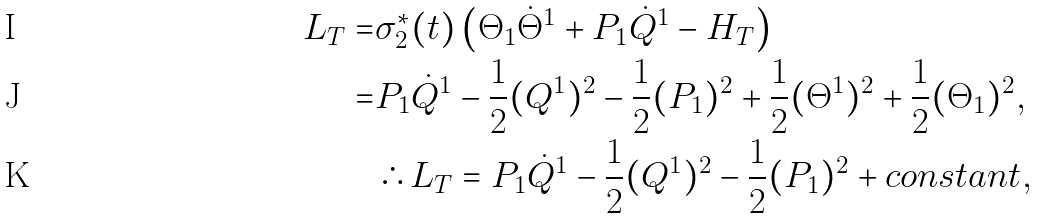<formula> <loc_0><loc_0><loc_500><loc_500>L _ { T } = & \sigma ^ { * } _ { 2 } ( t ) \left ( \Theta _ { 1 } \dot { \Theta } ^ { 1 } + P _ { 1 } \dot { Q } ^ { 1 } - H _ { T } \right ) \\ = & P _ { 1 } \dot { Q } ^ { 1 } - \frac { 1 } { 2 } ( Q ^ { 1 } ) ^ { 2 } - \frac { 1 } { 2 } ( P _ { 1 } ) ^ { 2 } + \frac { 1 } { 2 } ( \Theta ^ { 1 } ) ^ { 2 } + \frac { 1 } { 2 } ( \Theta _ { 1 } ) ^ { 2 } , \\ & \therefore L _ { T } = P _ { 1 } \dot { Q } ^ { 1 } - \frac { 1 } { 2 } ( Q ^ { 1 } ) ^ { 2 } - \frac { 1 } { 2 } ( P _ { 1 } ) ^ { 2 } + { c o n s t a n t } ,</formula> 